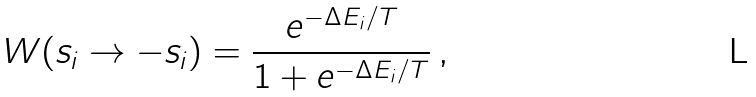Convert formula to latex. <formula><loc_0><loc_0><loc_500><loc_500>W ( s _ { i } \to - s _ { i } ) = \frac { e ^ { - \Delta E _ { i } / T } } { 1 + e ^ { - \Delta E _ { i } / T } } \, ,</formula> 